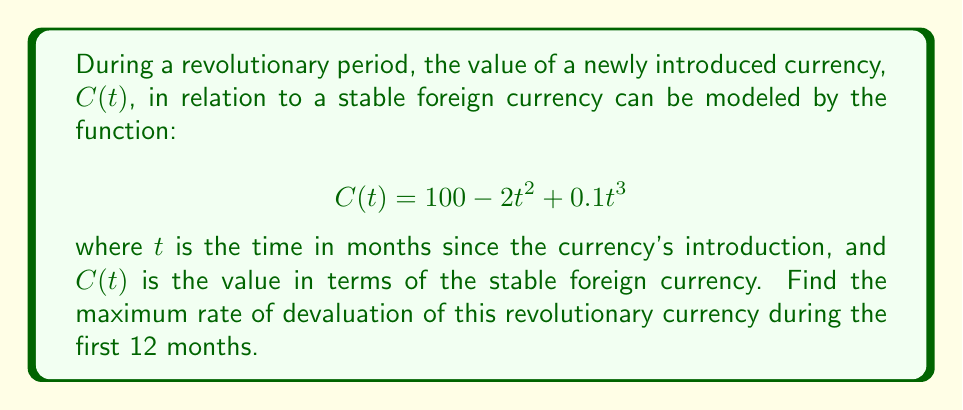Show me your answer to this math problem. To find the maximum rate of devaluation, we need to follow these steps:

1) First, we need to find the rate of change of the currency's value. This is given by the derivative of C(t):

   $$C'(t) = -4t + 0.3t^2$$

2) The rate of devaluation is the negative of this, so we're looking for the minimum value of C'(t):

   $$\text{Rate of devaluation} = -C'(t) = 4t - 0.3t^2$$

3) To find the maximum of this function within the first 12 months, we need to find where its derivative equals zero or evaluate the endpoints:

   $$\frac{d}{dt}(-C'(t)) = 4 - 0.6t$$

4) Setting this to zero:

   $$4 - 0.6t = 0$$
   $$t = \frac{4}{0.6} = \frac{20}{3} \approx 6.67$$

5) This critical point is within our interval [0, 12]. We need to compare the values at t = 0, t = 20/3, and t = 12:

   At t = 0: $-C'(0) = 0$
   At t = 20/3: $-C'(20/3) = 4(20/3) - 0.3(20/3)^2 = \frac{80}{3} - 40 = \frac{80}{3} - \frac{120}{3} = -\frac{40}{3} \approx 13.33$
   At t = 12: $-C'(12) = 4(12) - 0.3(12)^2 = 48 - 43.2 = 4.8$

6) The maximum value occurs at t = 20/3 months, approximately 6.67 months after the currency's introduction.

7) The maximum rate of devaluation is $\frac{40}{3}$ units of the stable foreign currency per month.
Answer: $\frac{40}{3}$ units per month 